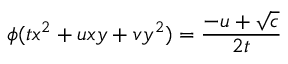Convert formula to latex. <formula><loc_0><loc_0><loc_500><loc_500>\phi ( t x ^ { 2 } + u x y + v y ^ { 2 } ) = { \frac { - u + { \sqrt { c } } } { 2 t } }</formula> 